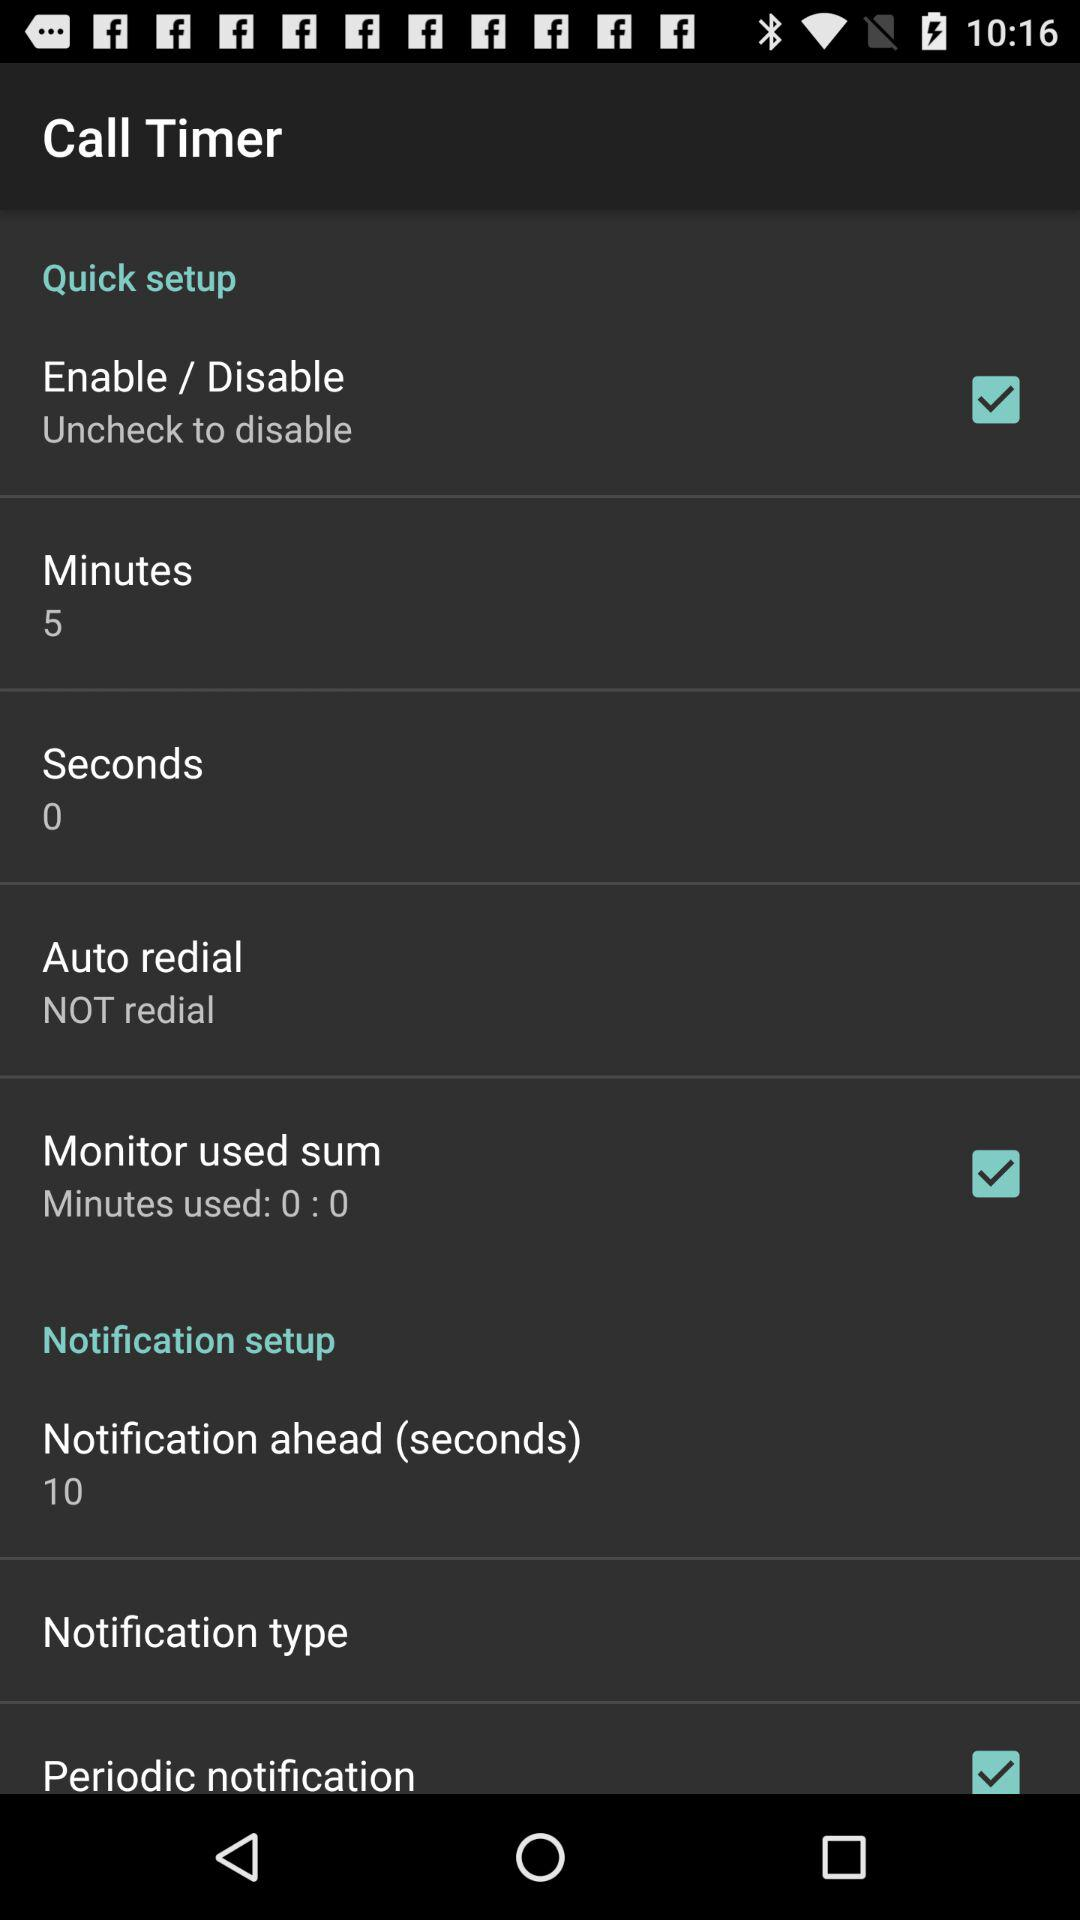How does quick set up setting in call timer works?
When the provided information is insufficient, respond with <no answer>. <no answer> 